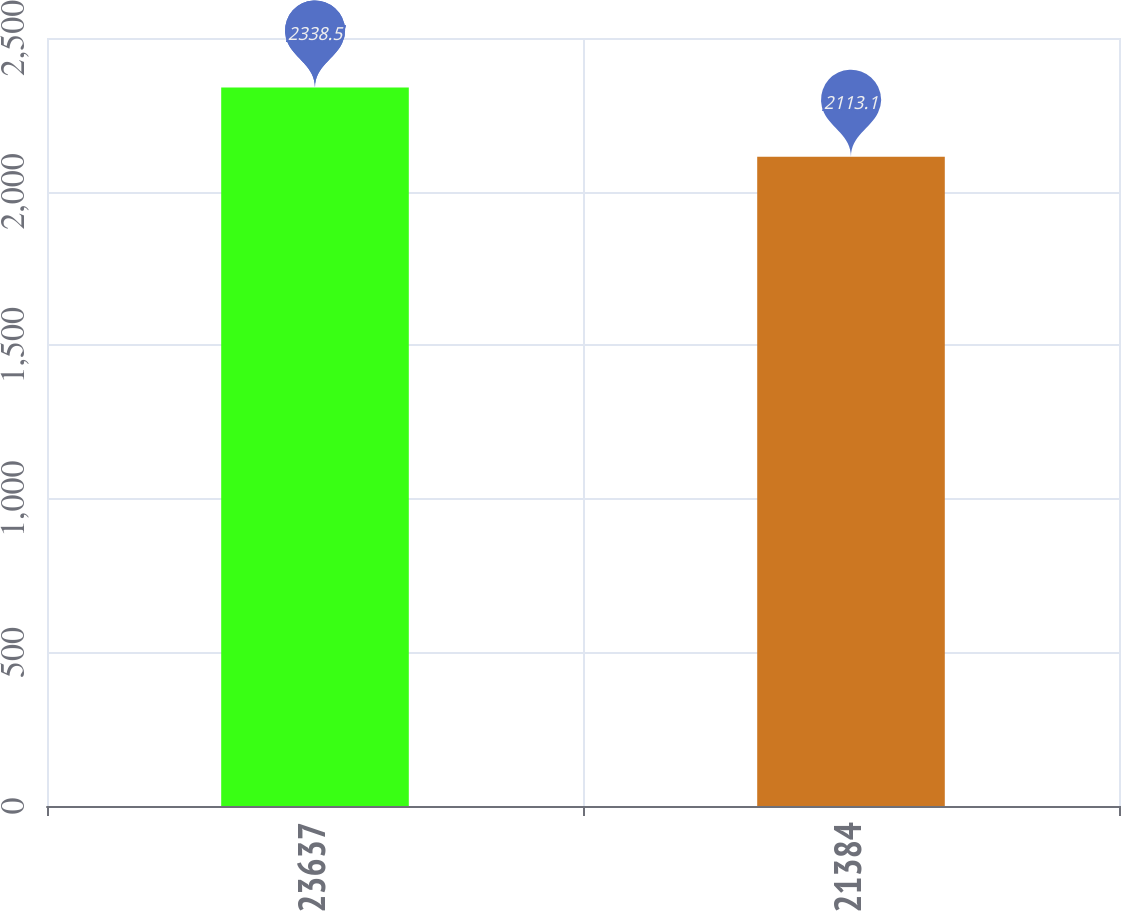Convert chart to OTSL. <chart><loc_0><loc_0><loc_500><loc_500><bar_chart><fcel>23637<fcel>21384<nl><fcel>2338.5<fcel>2113.1<nl></chart> 